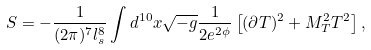<formula> <loc_0><loc_0><loc_500><loc_500>S = - \frac { 1 } { ( 2 \pi ) ^ { 7 } l _ { s } ^ { 8 } } \int d ^ { 1 0 } x \sqrt { - g } \frac { 1 } { 2 e ^ { 2 \phi } } \left [ ( \partial T ) ^ { 2 } + M _ { T } ^ { 2 } T ^ { 2 } \right ] ,</formula> 